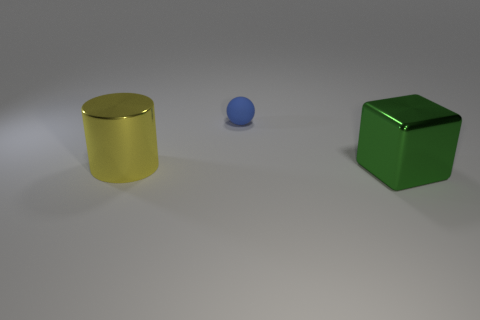Are there any large cylinders that have the same material as the green thing?
Provide a short and direct response. Yes. Is the large block the same color as the tiny rubber ball?
Provide a short and direct response. No. There is a object that is right of the big yellow shiny object and in front of the sphere; what material is it made of?
Your response must be concise. Metal. The big block has what color?
Offer a terse response. Green. How many other matte things are the same shape as the yellow thing?
Ensure brevity in your answer.  0. Is the large object that is on the right side of the tiny blue matte thing made of the same material as the big object to the left of the blue matte object?
Keep it short and to the point. Yes. There is a shiny cube in front of the large object behind the green metallic object; what size is it?
Ensure brevity in your answer.  Large. Is there any other thing that is the same size as the yellow shiny object?
Your answer should be very brief. Yes. There is a large metal object that is on the left side of the metallic cube; is it the same shape as the metal object that is right of the small ball?
Offer a very short reply. No. Is the number of small yellow blocks greater than the number of large green shiny blocks?
Provide a succinct answer. No. 